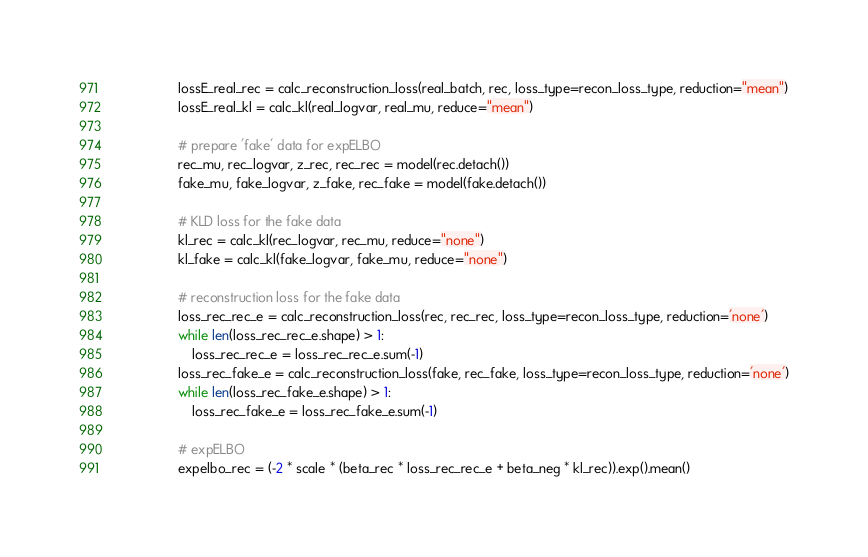Convert code to text. <code><loc_0><loc_0><loc_500><loc_500><_Python_>
                lossE_real_rec = calc_reconstruction_loss(real_batch, rec, loss_type=recon_loss_type, reduction="mean")
                lossE_real_kl = calc_kl(real_logvar, real_mu, reduce="mean")

                # prepare 'fake' data for expELBO
                rec_mu, rec_logvar, z_rec, rec_rec = model(rec.detach())
                fake_mu, fake_logvar, z_fake, rec_fake = model(fake.detach())

                # KLD loss for the fake data
                kl_rec = calc_kl(rec_logvar, rec_mu, reduce="none")
                kl_fake = calc_kl(fake_logvar, fake_mu, reduce="none")

                # reconstruction loss for the fake data
                loss_rec_rec_e = calc_reconstruction_loss(rec, rec_rec, loss_type=recon_loss_type, reduction='none')
                while len(loss_rec_rec_e.shape) > 1:
                    loss_rec_rec_e = loss_rec_rec_e.sum(-1)
                loss_rec_fake_e = calc_reconstruction_loss(fake, rec_fake, loss_type=recon_loss_type, reduction='none')
                while len(loss_rec_fake_e.shape) > 1:
                    loss_rec_fake_e = loss_rec_fake_e.sum(-1)

                # expELBO
                expelbo_rec = (-2 * scale * (beta_rec * loss_rec_rec_e + beta_neg * kl_rec)).exp().mean()</code> 